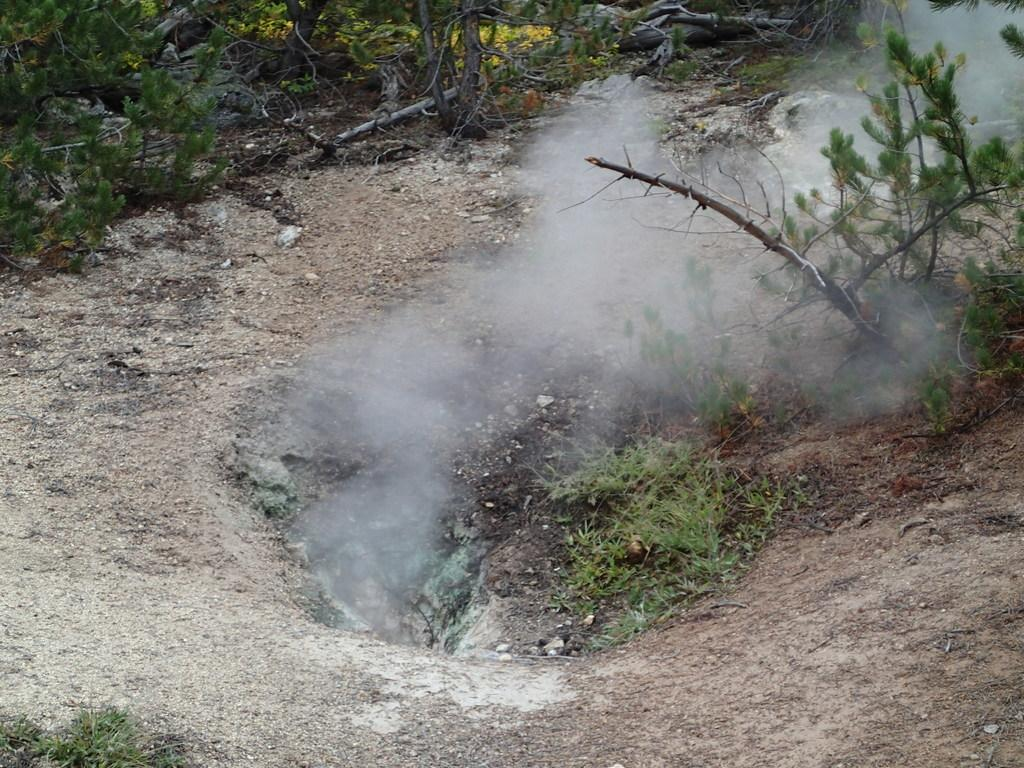What can be seen in the middle of the image? There is smoke in the middle of the image. What type of vegetation is present in the image? There are plants in the image. What is covering the ground in the image? There is grass on the ground in the image. What type of learning system is visible in the image? There is no learning system present in the image; it features smoke, plants, and grass. How does the carriage move in the image? There is no carriage present in the image. 